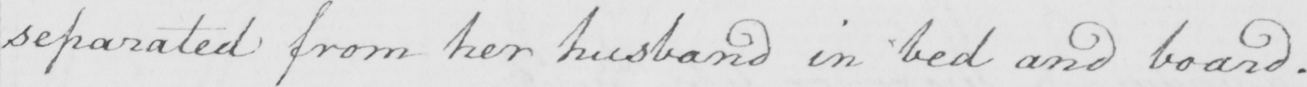Transcribe the text shown in this historical manuscript line. separated from her husband in bed and board . 